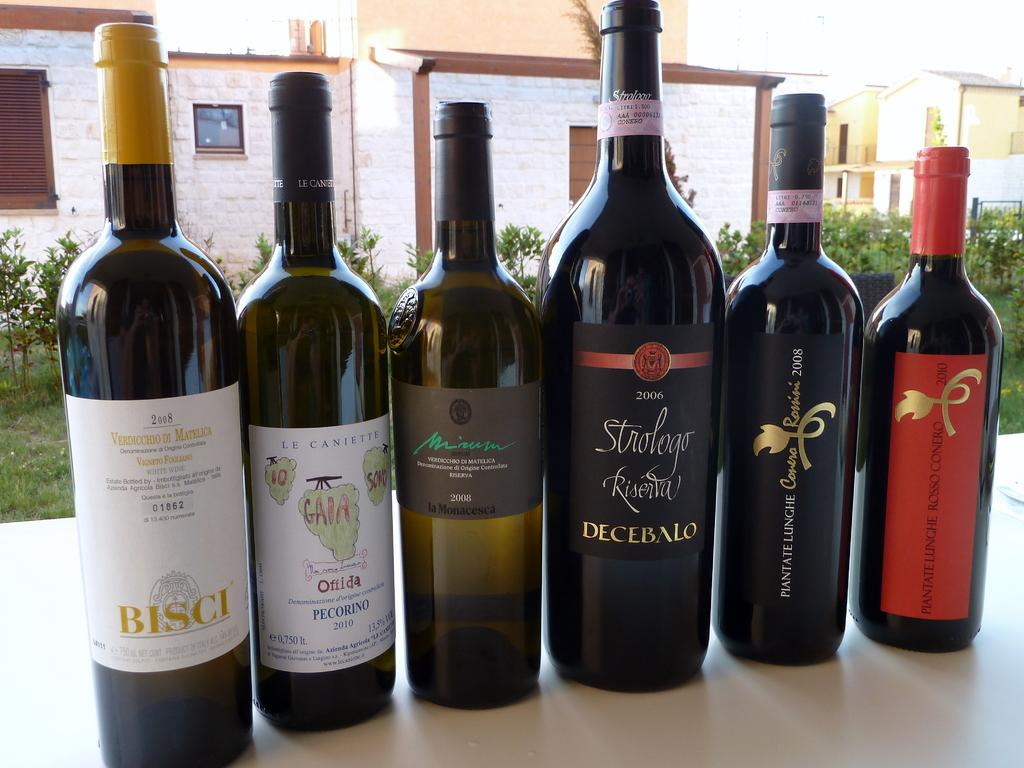<image>
Share a concise interpretation of the image provided. Bottles of wine including a bottle of Decebalo. 